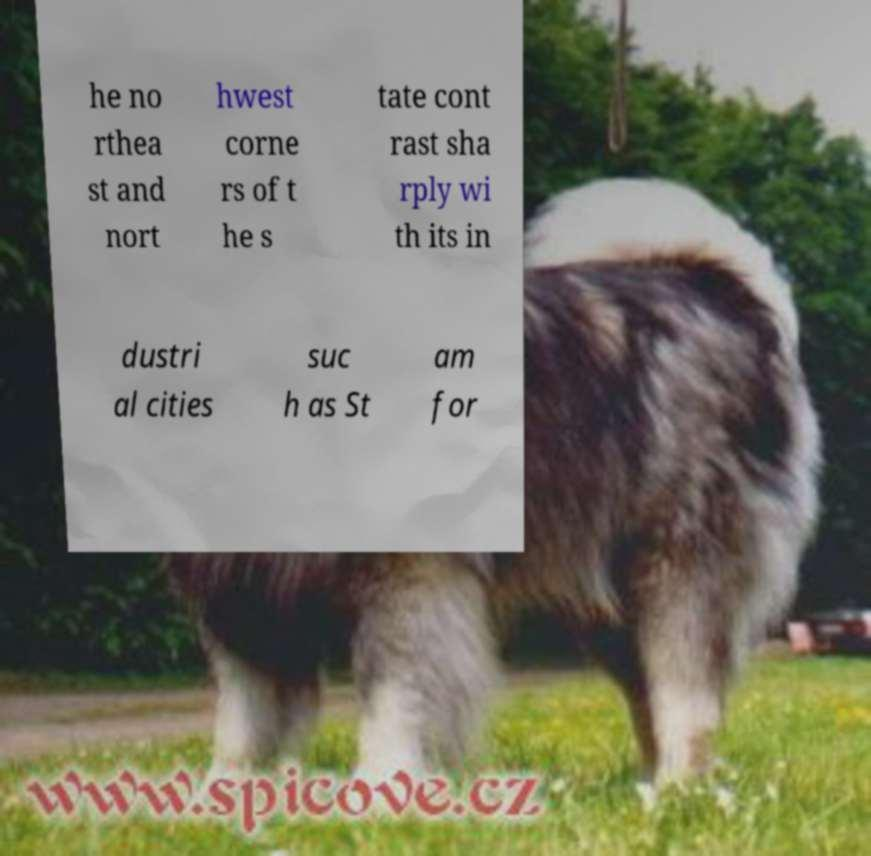For documentation purposes, I need the text within this image transcribed. Could you provide that? he no rthea st and nort hwest corne rs of t he s tate cont rast sha rply wi th its in dustri al cities suc h as St am for 